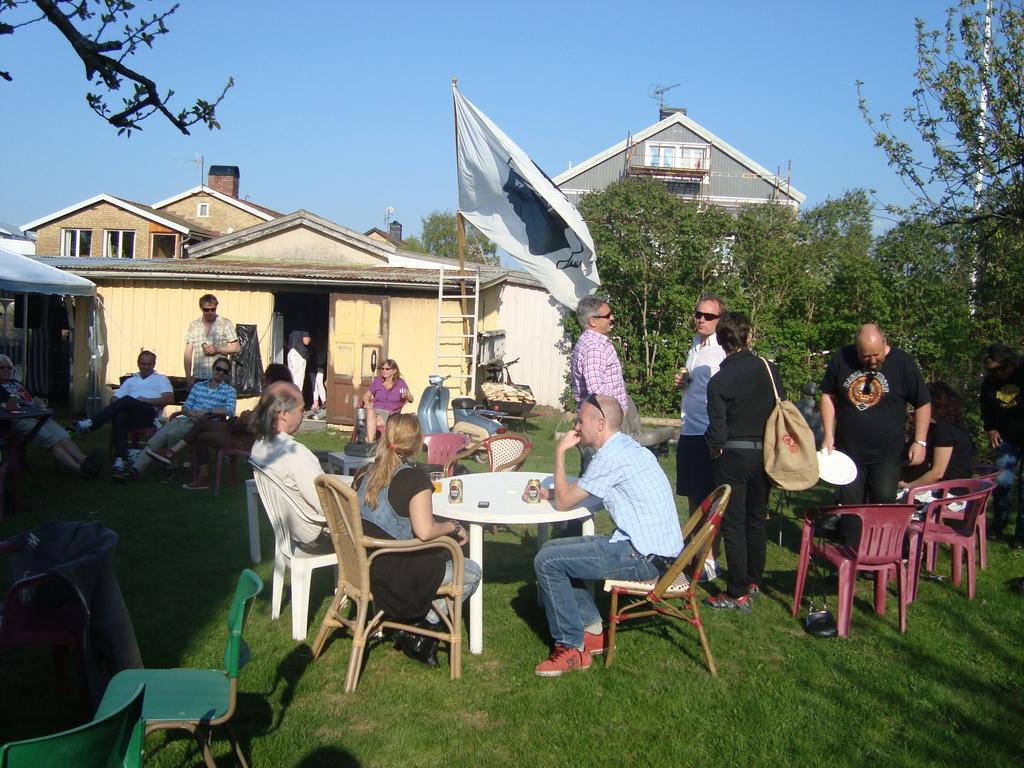Please provide a concise description of this image. There are group of people in the image some are siting and few are standing. There is a vehicle and a flag in the middle of the image, there is a building at the background and at the right side of the image there is a tree and at the top of the image there is a sky. 